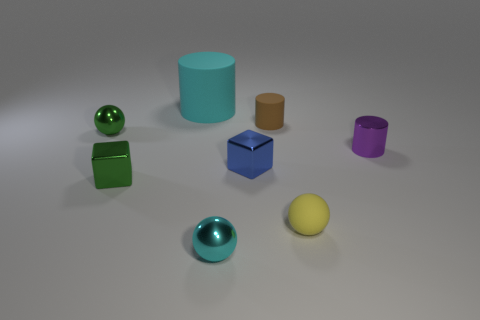Subtract all big cyan cylinders. How many cylinders are left? 2 Add 1 yellow spheres. How many objects exist? 9 Subtract 1 spheres. How many spheres are left? 2 Add 1 big matte cylinders. How many big matte cylinders exist? 2 Subtract 1 purple cylinders. How many objects are left? 7 Subtract all spheres. How many objects are left? 5 Subtract all green cylinders. Subtract all purple spheres. How many cylinders are left? 3 Subtract all large yellow metallic blocks. Subtract all tiny objects. How many objects are left? 1 Add 5 small brown cylinders. How many small brown cylinders are left? 6 